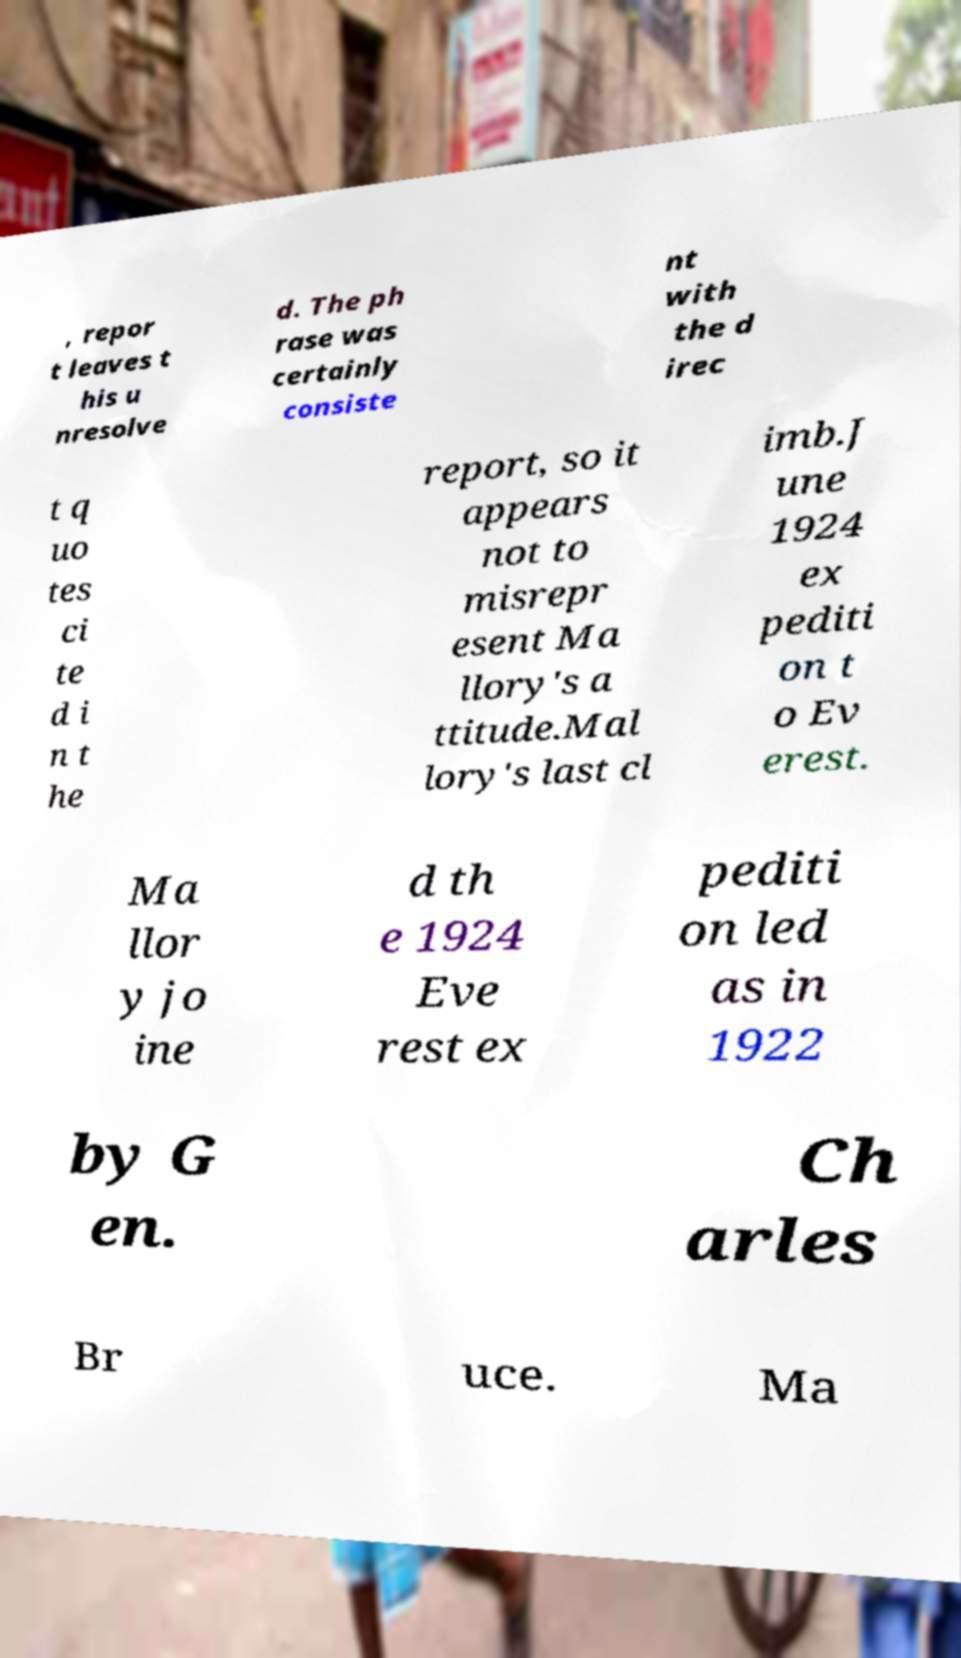Please read and relay the text visible in this image. What does it say? , repor t leaves t his u nresolve d. The ph rase was certainly consiste nt with the d irec t q uo tes ci te d i n t he report, so it appears not to misrepr esent Ma llory's a ttitude.Mal lory's last cl imb.J une 1924 ex pediti on t o Ev erest. Ma llor y jo ine d th e 1924 Eve rest ex pediti on led as in 1922 by G en. Ch arles Br uce. Ma 